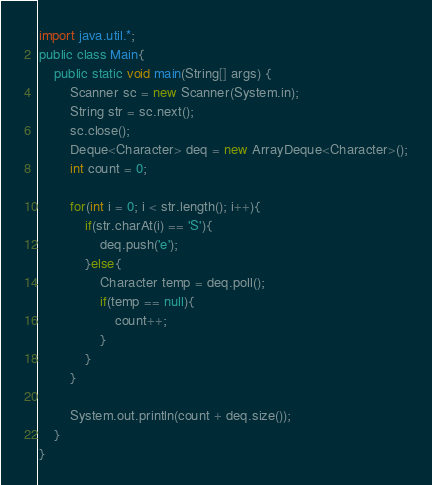<code> <loc_0><loc_0><loc_500><loc_500><_Java_>import java.util.*;
public class Main{
    public static void main(String[] args) {
        Scanner sc = new Scanner(System.in);
        String str = sc.next();
        sc.close();
        Deque<Character> deq = new ArrayDeque<Character>();
        int count = 0;

        for(int i = 0; i < str.length(); i++){
            if(str.charAt(i) == 'S'){
                deq.push('e');
            }else{
                Character temp = deq.poll();
                if(temp == null){
                    count++;
                }
            }
        }

        System.out.println(count + deq.size());
    }
}</code> 